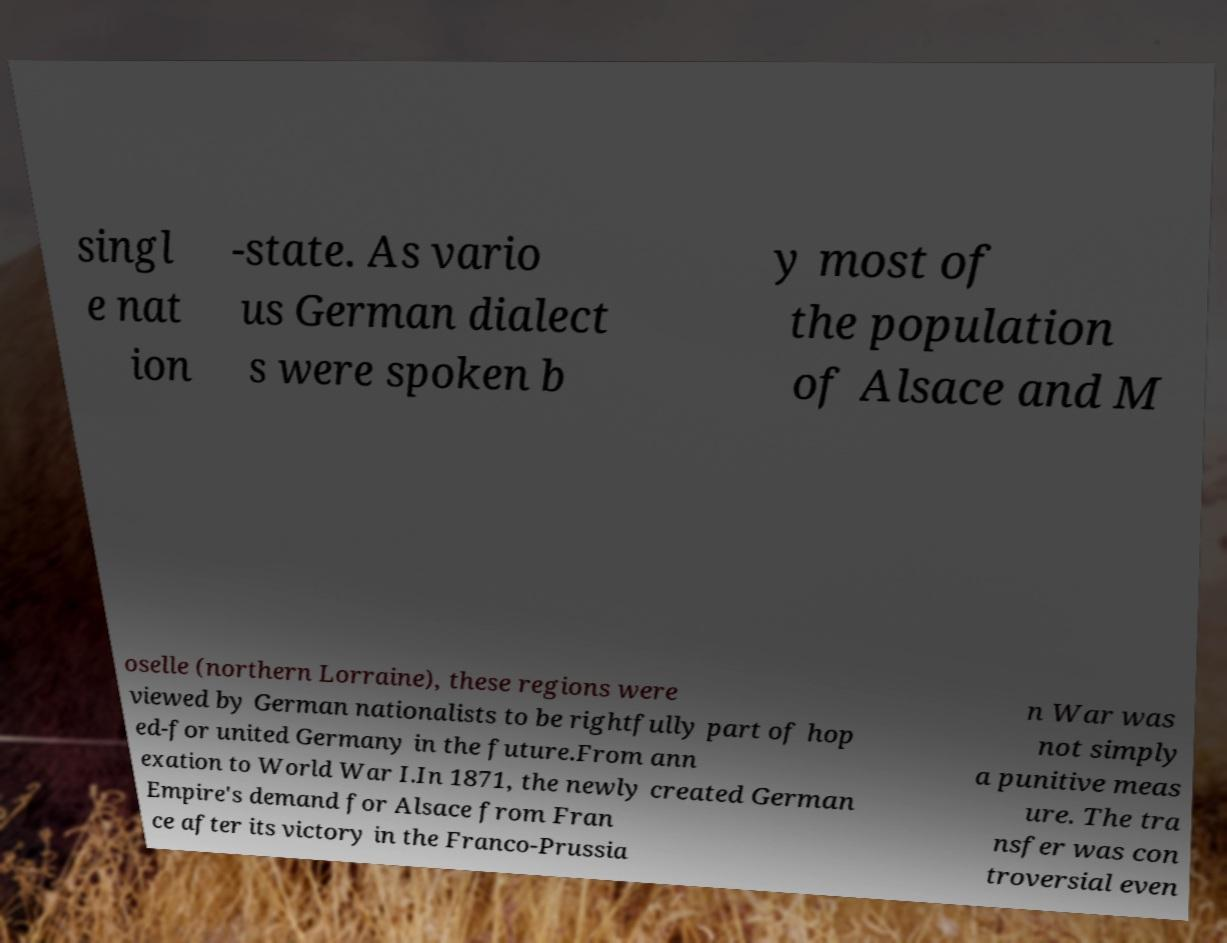What messages or text are displayed in this image? I need them in a readable, typed format. singl e nat ion -state. As vario us German dialect s were spoken b y most of the population of Alsace and M oselle (northern Lorraine), these regions were viewed by German nationalists to be rightfully part of hop ed-for united Germany in the future.From ann exation to World War I.In 1871, the newly created German Empire's demand for Alsace from Fran ce after its victory in the Franco-Prussia n War was not simply a punitive meas ure. The tra nsfer was con troversial even 